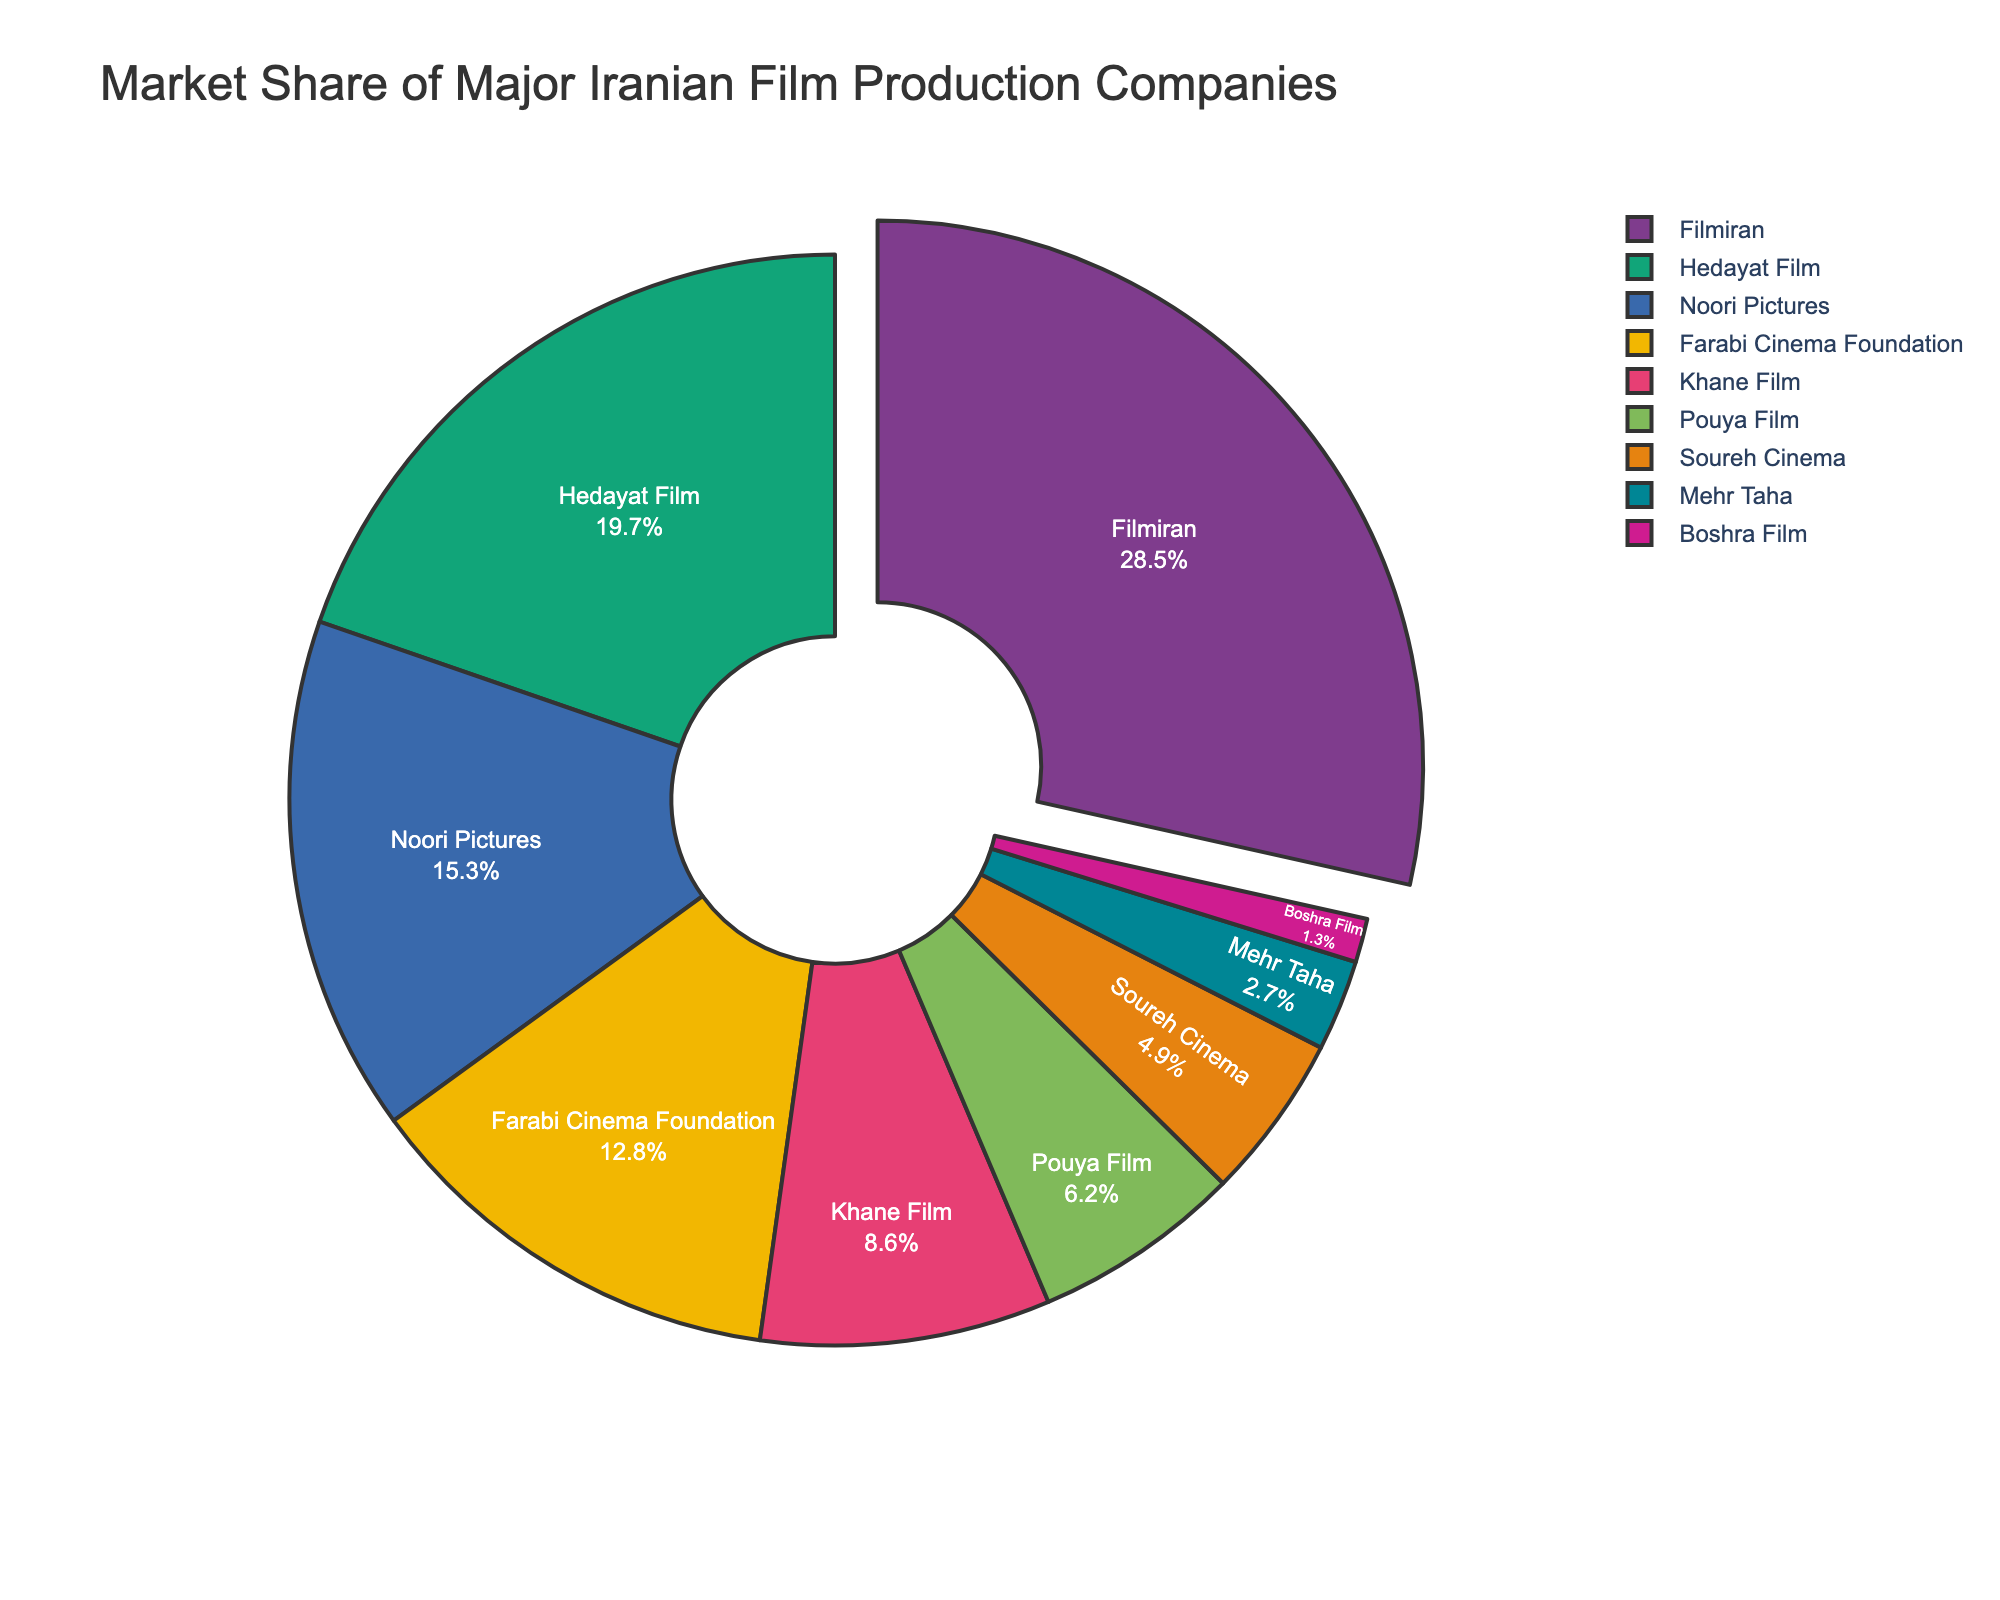Which company has the highest market share? The highest market share is indicated by the largest section of the pie chart. Filmiran occupies the largest portion of the chart.
Answer: Filmiran Which company has the smallest market share? The smallest market share is indicated by the smallest section of the pie chart. Boshra Film occupies the smallest portion of the chart.
Answer: Boshra Film What is the combined market share of Hedayat Film and Noori Pictures? Hedayat Film has a market share of 19.7% and Noori Pictures has 15.3%. Adding them together: 19.7 + 15.3 = 35%.
Answer: 35% How much larger is Filmiran's market share compared to Farabi Cinema Foundation's? Filmiran's market share is 28.5% and Farabi Cinema Foundation's market share is 12.8%. Subtracting the two: 28.5 - 12.8 = 15.7%.
Answer: 15.7% Are there any companies with exactly the same market share? By visually comparing the sizes of the pie chart segments and their percentages, no two companies have identical market shares.
Answer: No Which company occupies the second largest section after Filmiran? The second largest section after Filmiran's 28.5% is Hedayat Film with 19.7%.
Answer: Hedayat Film What percentage of the market is held by companies other than Filmiran, Hedayat Film, and Noori Pictures? Filmiran, Hedayat Film, and Noori Pictures have market shares of 28.5%, 19.7%, and 15.3% respectively. Summing these: 28.5 + 19.7 + 15.3 = 63.5%. Subtracting from 100%: 100 - 63.5 = 36.5%.
Answer: 36.5% Is Pouya Film's market share larger than Soureh Cinema's? By comparing their market shares from the chart, Pouya Film has 6.2% and Soureh Cinema has 4.9%.
Answer: Yes Name the top three companies in terms of market share. The top three companies with the largest market shares are Filmiran (28.5%), Hedayat Film (19.7%), and Noori Pictures (15.3%).
Answer: Filmiran, Hedayat Film, Noori Pictures What is the total market share of companies with less than 5% each? The companies with less than 5% market share are Soureh Cinema (4.9%), Mehr Taha (2.7%), and Boshra Film (1.3%). Summing these: 4.9 + 2.7 + 1.3 = 8.9%.
Answer: 8.9% 